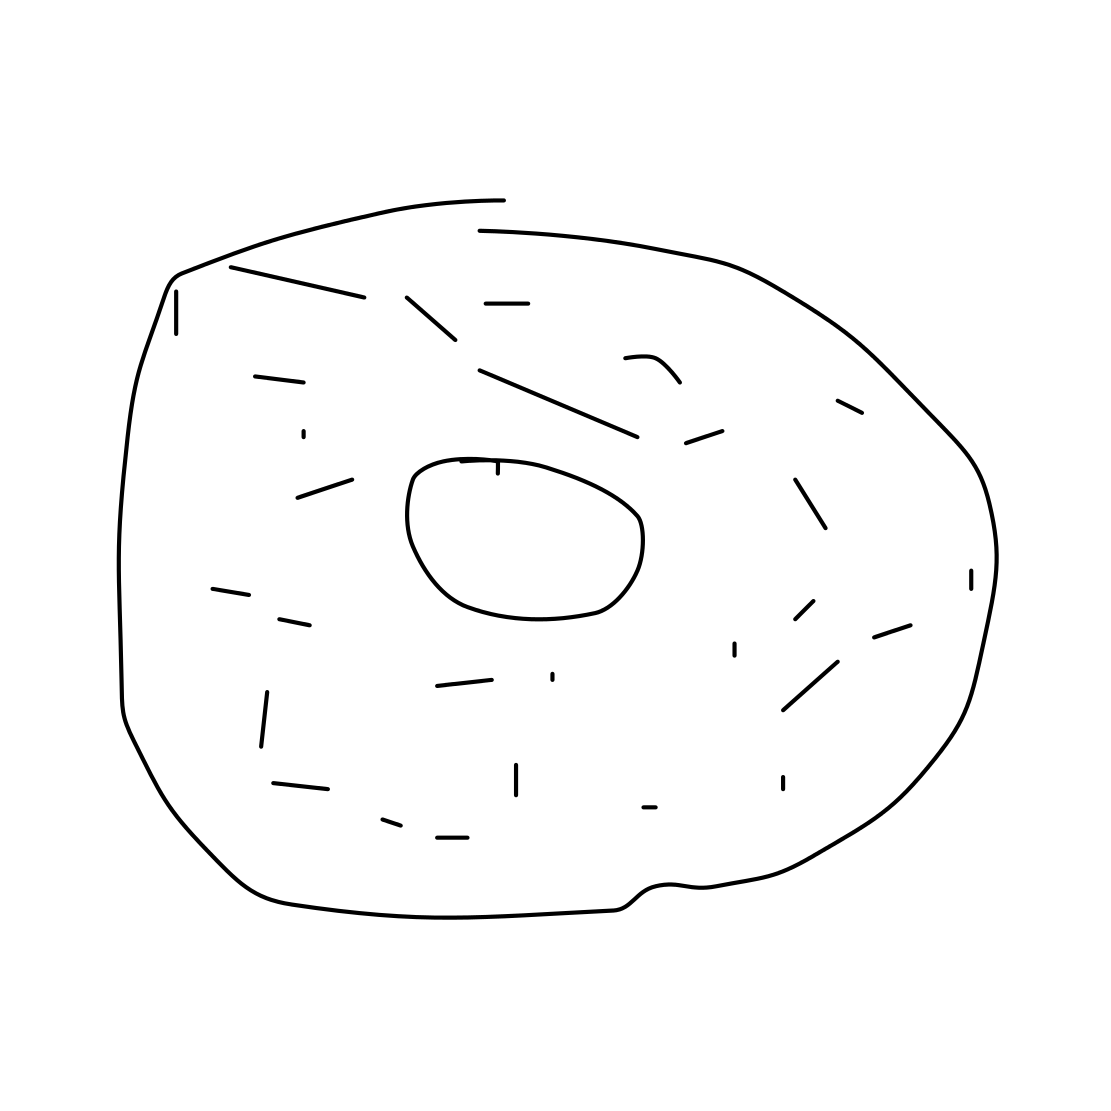Is this a donut in the image? Yes 